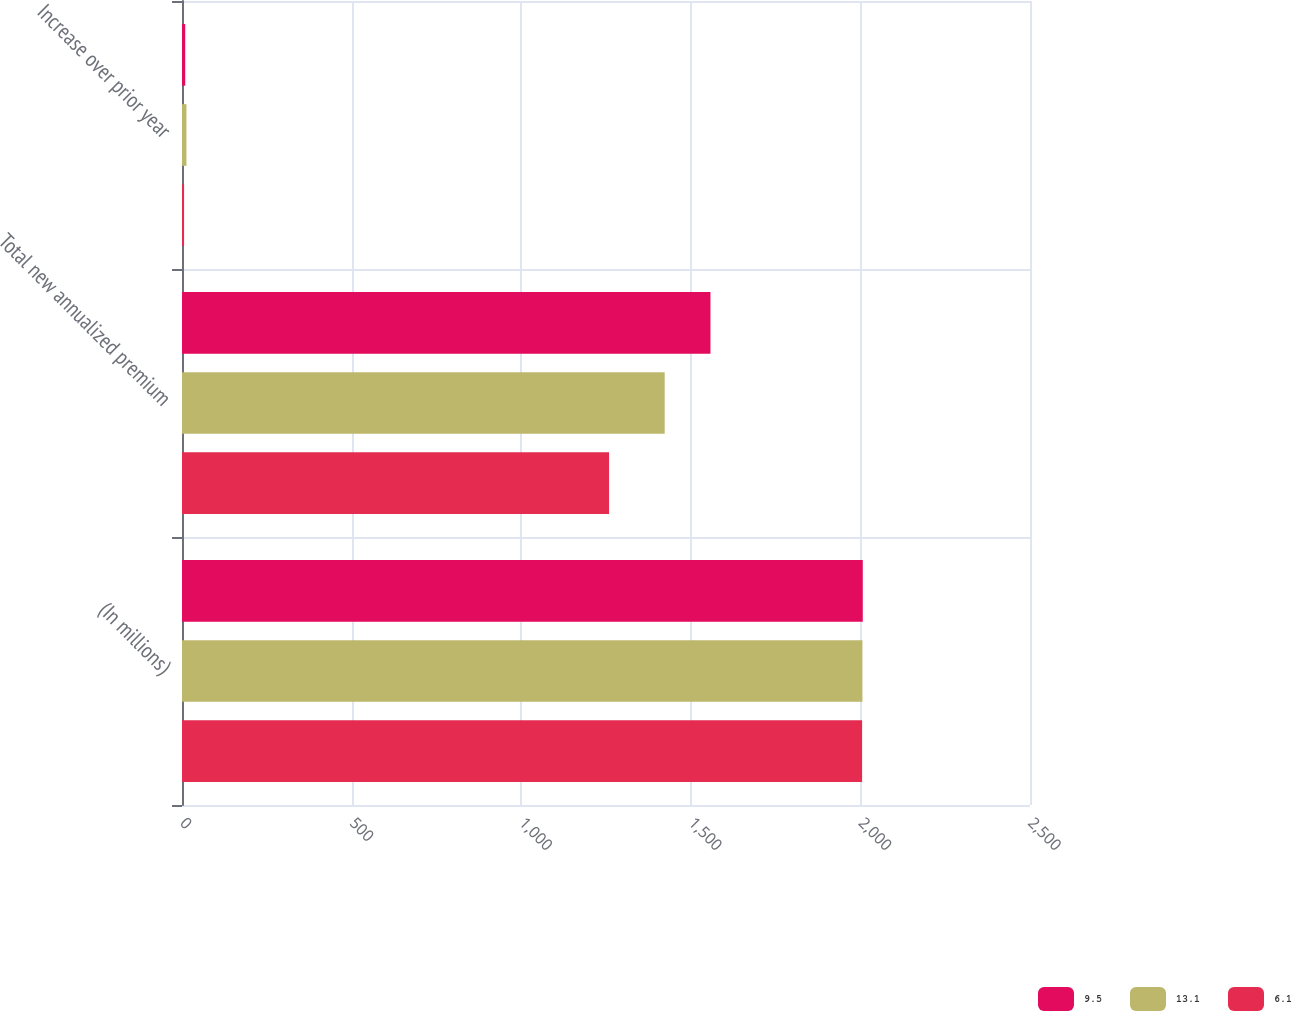<chart> <loc_0><loc_0><loc_500><loc_500><stacked_bar_chart><ecel><fcel>(In millions)<fcel>Total new annualized premium<fcel>Increase over prior year<nl><fcel>9.5<fcel>2007<fcel>1558<fcel>9.5<nl><fcel>13.1<fcel>2006<fcel>1423<fcel>13.1<nl><fcel>6.1<fcel>2005<fcel>1259<fcel>6.1<nl></chart> 